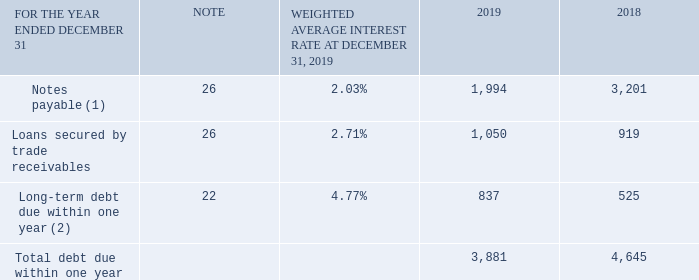Note 21 Debt due within one year
(1) Includes commercial paper of $1,502 million in U.S. dollars ($1,951 million in Canadian dollars) and $2,314 million in U.S. dollars ($3,156 million in Canadian dollars) as at December 31, 2019 and December 31, 2018, respectively, which were issued under our U.S. commercial paper program and have been hedged for foreign currency fluctuations through forward currency contracts. See Note 26, Financial and capital management, for additional details.
(2) Included in long-term debt due within one year is the current portion of lease liabilities of $775 million as at December 31, 2019 and the current portion of finance leases of $466 million as at December 31, 2018.
How are the notes payable hedged? Hedged for foreign currency fluctuations through forward currency contracts. How are the commercial papers issued? Issued under our u.s. commercial paper program. Which currencies are referenced in the context? U.s. dollars, canadian dollars. What is the total long-term debt due within one year in 2018 and 2019? 837+525
Answer: 1362. What is the difference in the weighted average interest rate for notes payable and loans secured by trade receivables?
Answer scale should be: percent. 2.71%-2.03%
Answer: 0.68. What is the percentage change in the total debt due within one year in 2019?
Answer scale should be: percent. (3,881-4,645)/4,645
Answer: -16.45. 